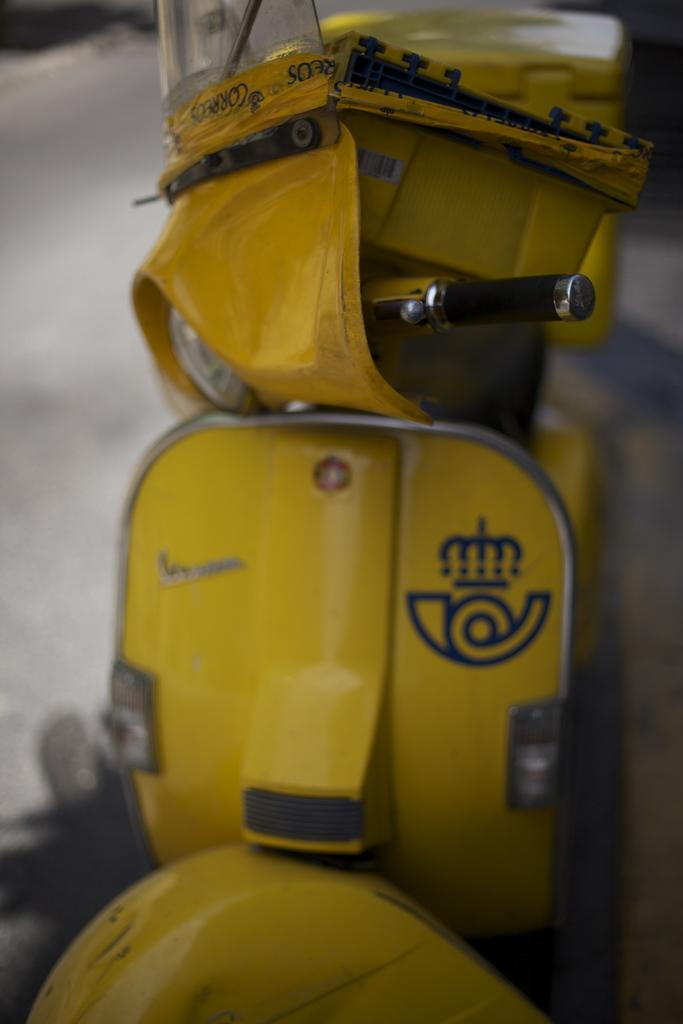What is the main subject of the image? The main subject of the image is a scooter on the road. What is on the scooter? There is an object and a box on the scooter. Can you describe the background of the image? The background of the image is blurry. What is the name of the person wearing a scarf in the image? There is no person wearing a scarf in the image; it only features a scooter with an object and a box on it. 